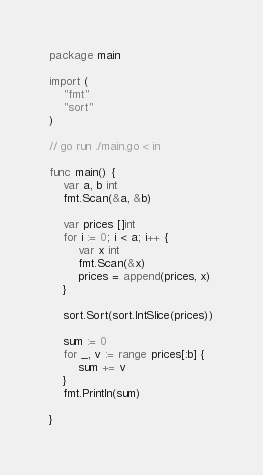Convert code to text. <code><loc_0><loc_0><loc_500><loc_500><_Go_>package main

import (
	"fmt"
	"sort"
)

// go run ./main.go < in

func main() {
	var a, b int
	fmt.Scan(&a, &b)

	var prices []int
	for i := 0; i < a; i++ {
		var x int
		fmt.Scan(&x)
		prices = append(prices, x)
	}

	sort.Sort(sort.IntSlice(prices))

	sum := 0
	for _, v := range prices[:b] {
		sum += v
	}
	fmt.Println(sum)

}
</code> 